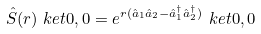Convert formula to latex. <formula><loc_0><loc_0><loc_500><loc_500>\hat { S } ( r ) \ k e t { 0 , 0 } = e ^ { r ( \hat { a } _ { 1 } \hat { a } _ { 2 } - \hat { a } _ { 1 } ^ { \dagger } \hat { a } _ { 2 } ^ { \dagger } ) } \ k e t { 0 , 0 }</formula> 